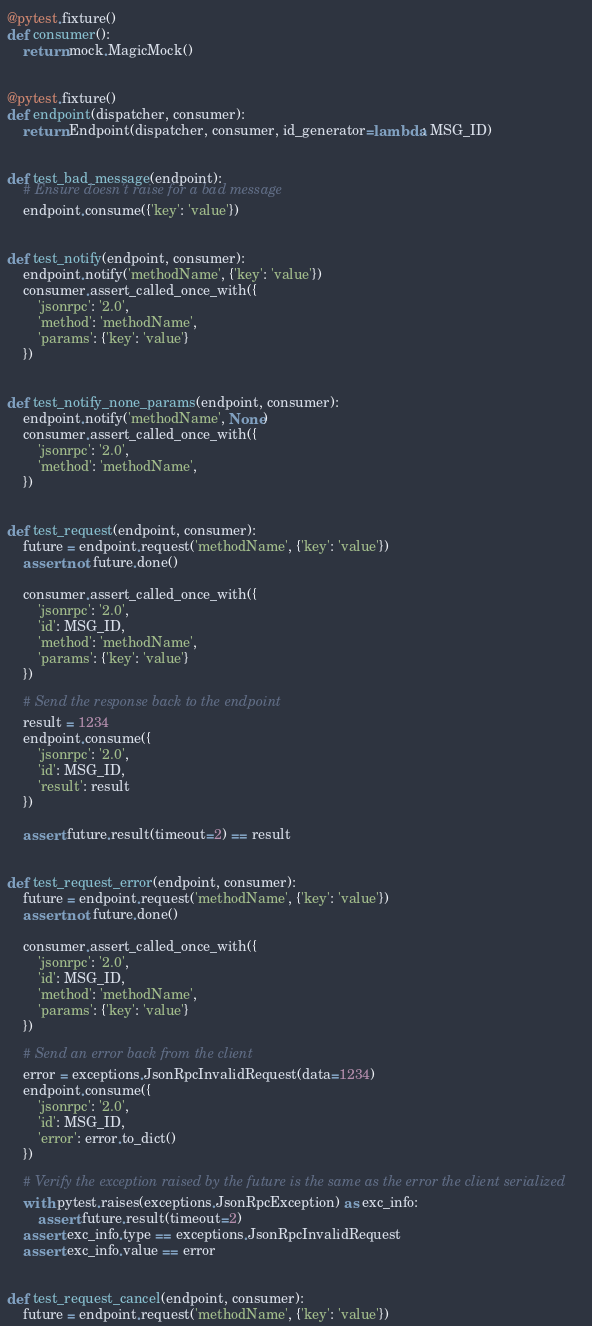<code> <loc_0><loc_0><loc_500><loc_500><_Python_>
@pytest.fixture()
def consumer():
    return mock.MagicMock()


@pytest.fixture()
def endpoint(dispatcher, consumer):
    return Endpoint(dispatcher, consumer, id_generator=lambda: MSG_ID)


def test_bad_message(endpoint):
    # Ensure doesn't raise for a bad message
    endpoint.consume({'key': 'value'})


def test_notify(endpoint, consumer):
    endpoint.notify('methodName', {'key': 'value'})
    consumer.assert_called_once_with({
        'jsonrpc': '2.0',
        'method': 'methodName',
        'params': {'key': 'value'}
    })


def test_notify_none_params(endpoint, consumer):
    endpoint.notify('methodName', None)
    consumer.assert_called_once_with({
        'jsonrpc': '2.0',
        'method': 'methodName',
    })


def test_request(endpoint, consumer):
    future = endpoint.request('methodName', {'key': 'value'})
    assert not future.done()

    consumer.assert_called_once_with({
        'jsonrpc': '2.0',
        'id': MSG_ID,
        'method': 'methodName',
        'params': {'key': 'value'}
    })

    # Send the response back to the endpoint
    result = 1234
    endpoint.consume({
        'jsonrpc': '2.0',
        'id': MSG_ID,
        'result': result
    })

    assert future.result(timeout=2) == result


def test_request_error(endpoint, consumer):
    future = endpoint.request('methodName', {'key': 'value'})
    assert not future.done()

    consumer.assert_called_once_with({
        'jsonrpc': '2.0',
        'id': MSG_ID,
        'method': 'methodName',
        'params': {'key': 'value'}
    })

    # Send an error back from the client
    error = exceptions.JsonRpcInvalidRequest(data=1234)
    endpoint.consume({
        'jsonrpc': '2.0',
        'id': MSG_ID,
        'error': error.to_dict()
    })

    # Verify the exception raised by the future is the same as the error the client serialized
    with pytest.raises(exceptions.JsonRpcException) as exc_info:
        assert future.result(timeout=2)
    assert exc_info.type == exceptions.JsonRpcInvalidRequest
    assert exc_info.value == error


def test_request_cancel(endpoint, consumer):
    future = endpoint.request('methodName', {'key': 'value'})</code> 